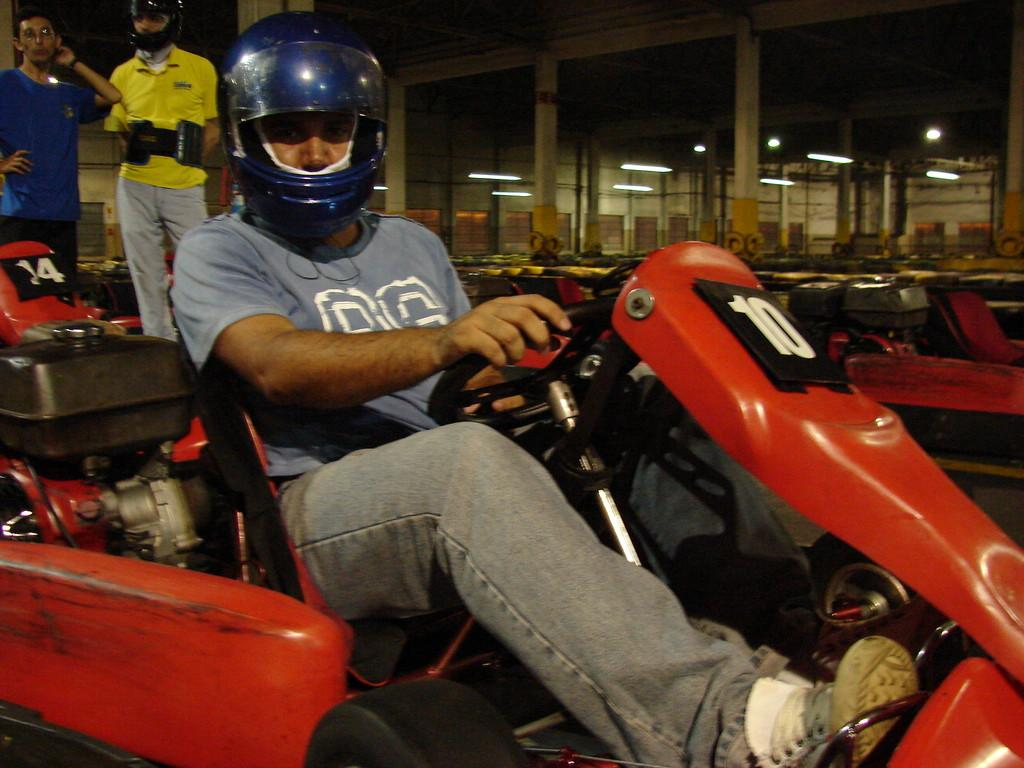What is the man in the image doing? The man is sitting on a go kart vehicle. What safety precaution is the man taking? The man is wearing a helmet. Can you describe the background of the image? In the background, there are two men standing on the left side. What type of tank can be seen in the image? There is no tank present in the image. Are there any firemen visible in the image? There is no indication of firemen in the image. 